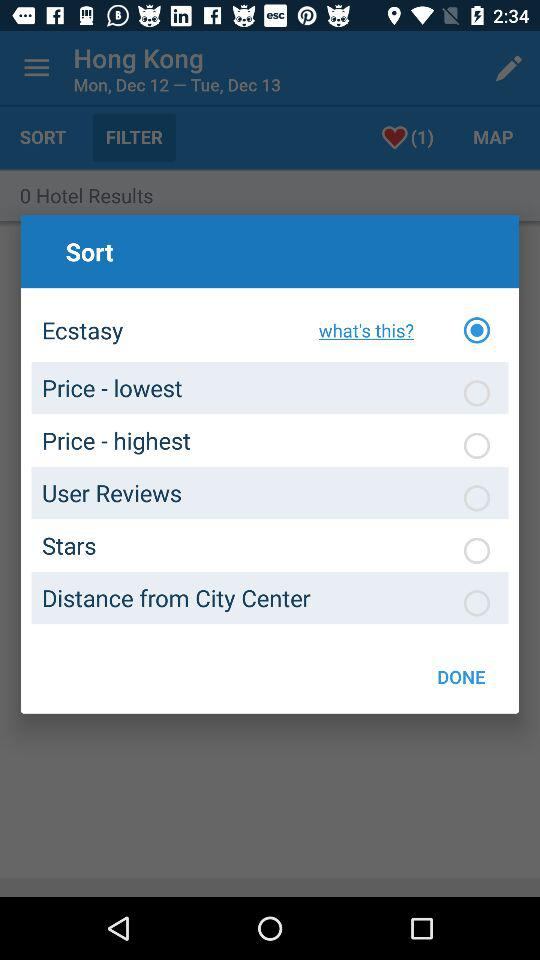Which option has a checked radio button? The option that has a checked radio button is "Ecstasy". 